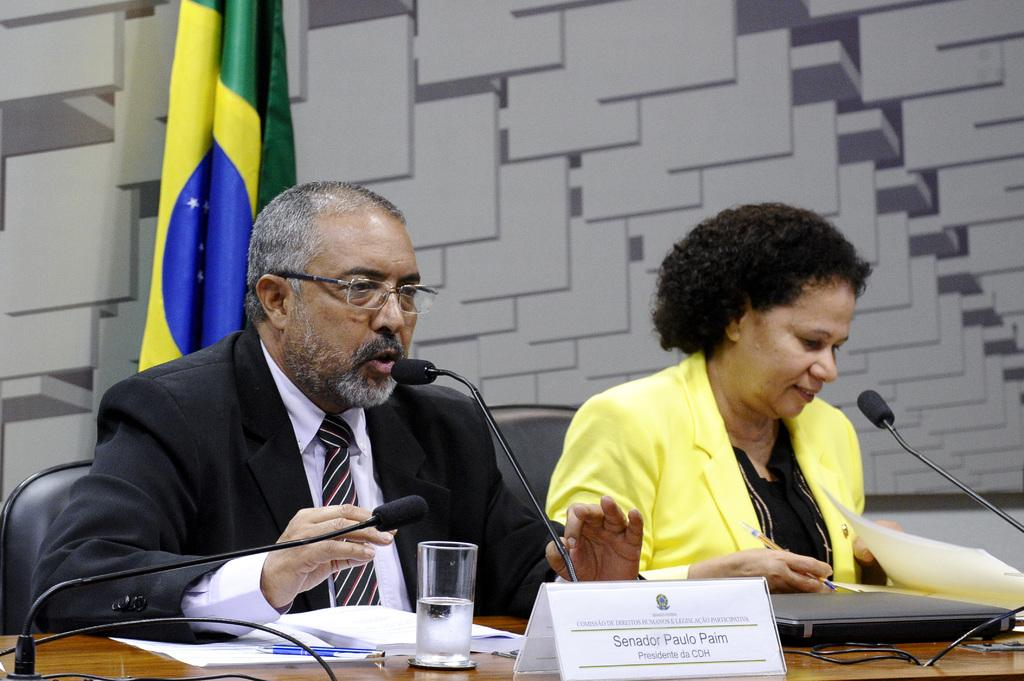How many people are in the image? There are 2 people in the image. What are the people doing in the image? The people are sitting on chairs. What are the people wearing in the image? The people are wearing blazers. What is in front of the people? There is a table in front of the people. What items can be seen on the table? There are microphones, papers, pens, glasses, and name plates on the table. Is there any symbol or emblem visible in the image? Yes, there is a flag visible in the image. How many dolls are sitting on the chairs with the people in the image? There are no dolls present in the image; only the 2 people are sitting on the chairs. What type of ornament is hanging from the flag in the image? There is no ornament hanging from the flag in the image; only the flag itself is visible. 